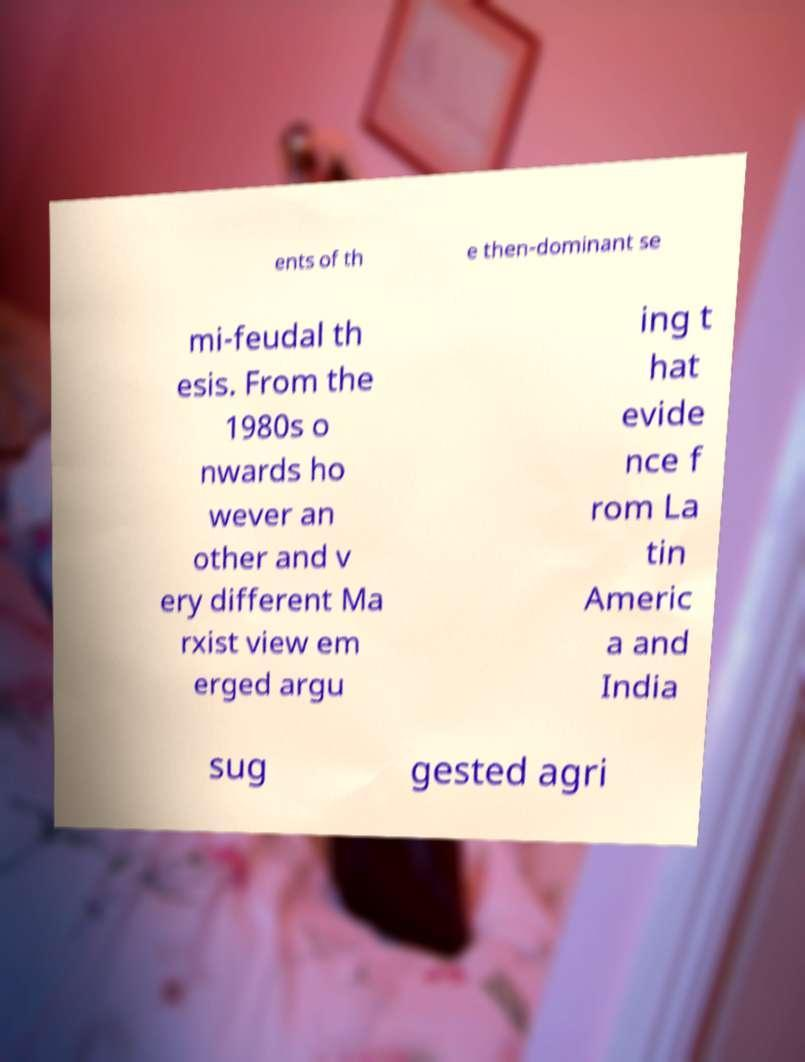Could you assist in decoding the text presented in this image and type it out clearly? ents of th e then-dominant se mi-feudal th esis. From the 1980s o nwards ho wever an other and v ery different Ma rxist view em erged argu ing t hat evide nce f rom La tin Americ a and India sug gested agri 